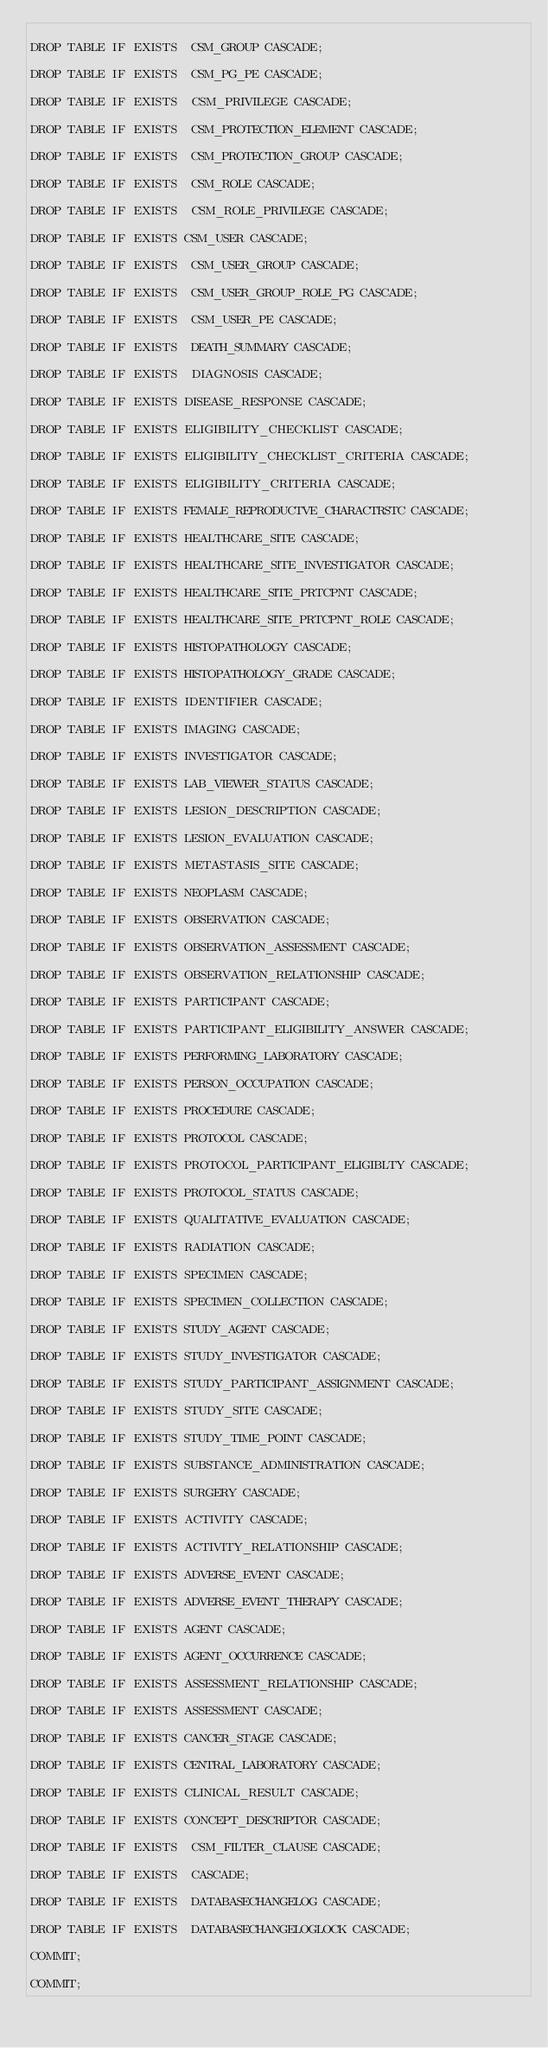Convert code to text. <code><loc_0><loc_0><loc_500><loc_500><_SQL_>
DROP TABLE IF EXISTS  CSM_GROUP CASCADE;

DROP TABLE IF EXISTS  CSM_PG_PE CASCADE;

DROP TABLE IF EXISTS  CSM_PRIVILEGE CASCADE;

DROP TABLE IF EXISTS  CSM_PROTECTION_ELEMENT CASCADE;

DROP TABLE IF EXISTS  CSM_PROTECTION_GROUP CASCADE;

DROP TABLE IF EXISTS  CSM_ROLE CASCADE;

DROP TABLE IF EXISTS  CSM_ROLE_PRIVILEGE CASCADE;

DROP TABLE IF EXISTS CSM_USER CASCADE;

DROP TABLE IF EXISTS  CSM_USER_GROUP CASCADE;

DROP TABLE IF EXISTS  CSM_USER_GROUP_ROLE_PG CASCADE;

DROP TABLE IF EXISTS  CSM_USER_PE CASCADE;

DROP TABLE IF EXISTS  DEATH_SUMMARY CASCADE;

DROP TABLE IF EXISTS  DIAGNOSIS CASCADE;

DROP TABLE IF EXISTS DISEASE_RESPONSE CASCADE;

DROP TABLE IF EXISTS ELIGIBILITY_CHECKLIST CASCADE;

DROP TABLE IF EXISTS ELIGIBILITY_CHECKLIST_CRITERIA CASCADE;

DROP TABLE IF EXISTS ELIGIBILITY_CRITERIA CASCADE;

DROP TABLE IF EXISTS FEMALE_REPRODUCTVE_CHARACTRSTC CASCADE;

DROP TABLE IF EXISTS HEALTHCARE_SITE CASCADE;

DROP TABLE IF EXISTS HEALTHCARE_SITE_INVESTIGATOR CASCADE;

DROP TABLE IF EXISTS HEALTHCARE_SITE_PRTCPNT CASCADE;

DROP TABLE IF EXISTS HEALTHCARE_SITE_PRTCPNT_ROLE CASCADE;

DROP TABLE IF EXISTS HISTOPATHOLOGY CASCADE;

DROP TABLE IF EXISTS HISTOPATHOLOGY_GRADE CASCADE;

DROP TABLE IF EXISTS IDENTIFIER CASCADE;

DROP TABLE IF EXISTS IMAGING CASCADE;

DROP TABLE IF EXISTS INVESTIGATOR CASCADE;

DROP TABLE IF EXISTS LAB_VIEWER_STATUS CASCADE;

DROP TABLE IF EXISTS LESION_DESCRIPTION CASCADE;

DROP TABLE IF EXISTS LESION_EVALUATION CASCADE;

DROP TABLE IF EXISTS METASTASIS_SITE CASCADE;

DROP TABLE IF EXISTS NEOPLASM CASCADE;

DROP TABLE IF EXISTS OBSERVATION CASCADE;

DROP TABLE IF EXISTS OBSERVATION_ASSESSMENT CASCADE;

DROP TABLE IF EXISTS OBSERVATION_RELATIONSHIP CASCADE;

DROP TABLE IF EXISTS PARTICIPANT CASCADE;

DROP TABLE IF EXISTS PARTICIPANT_ELIGIBILITY_ANSWER CASCADE;

DROP TABLE IF EXISTS PERFORMING_LABORATORY CASCADE;

DROP TABLE IF EXISTS PERSON_OCCUPATION CASCADE;

DROP TABLE IF EXISTS PROCEDURE CASCADE;

DROP TABLE IF EXISTS PROTOCOL CASCADE;

DROP TABLE IF EXISTS PROTOCOL_PARTICIPANT_ELIGIBLTY CASCADE;

DROP TABLE IF EXISTS PROTOCOL_STATUS CASCADE;

DROP TABLE IF EXISTS QUALITATIVE_EVALUATION CASCADE;

DROP TABLE IF EXISTS RADIATION CASCADE;

DROP TABLE IF EXISTS SPECIMEN CASCADE;

DROP TABLE IF EXISTS SPECIMEN_COLLECTION CASCADE;

DROP TABLE IF EXISTS STUDY_AGENT CASCADE;

DROP TABLE IF EXISTS STUDY_INVESTIGATOR CASCADE;

DROP TABLE IF EXISTS STUDY_PARTICIPANT_ASSIGNMENT CASCADE;

DROP TABLE IF EXISTS STUDY_SITE CASCADE;

DROP TABLE IF EXISTS STUDY_TIME_POINT CASCADE;

DROP TABLE IF EXISTS SUBSTANCE_ADMINISTRATION CASCADE;

DROP TABLE IF EXISTS SURGERY CASCADE;

DROP TABLE IF EXISTS ACTIVITY CASCADE;

DROP TABLE IF EXISTS ACTIVITY_RELATIONSHIP CASCADE;

DROP TABLE IF EXISTS ADVERSE_EVENT CASCADE;

DROP TABLE IF EXISTS ADVERSE_EVENT_THERAPY CASCADE;

DROP TABLE IF EXISTS AGENT CASCADE;

DROP TABLE IF EXISTS AGENT_OCCURRENCE CASCADE;

DROP TABLE IF EXISTS ASSESSMENT_RELATIONSHIP CASCADE;

DROP TABLE IF EXISTS ASSESSMENT CASCADE;

DROP TABLE IF EXISTS CANCER_STAGE CASCADE;

DROP TABLE IF EXISTS CENTRAL_LABORATORY CASCADE;

DROP TABLE IF EXISTS CLINICAL_RESULT CASCADE;

DROP TABLE IF EXISTS CONCEPT_DESCRIPTOR CASCADE;

DROP TABLE IF EXISTS  CSM_FILTER_CLAUSE CASCADE;

DROP TABLE IF EXISTS  CASCADE;

DROP TABLE IF EXISTS  DATABASECHANGELOG CASCADE;

DROP TABLE IF EXISTS  DATABASECHANGELOGLOCK CASCADE;

COMMIT;

COMMIT;</code> 